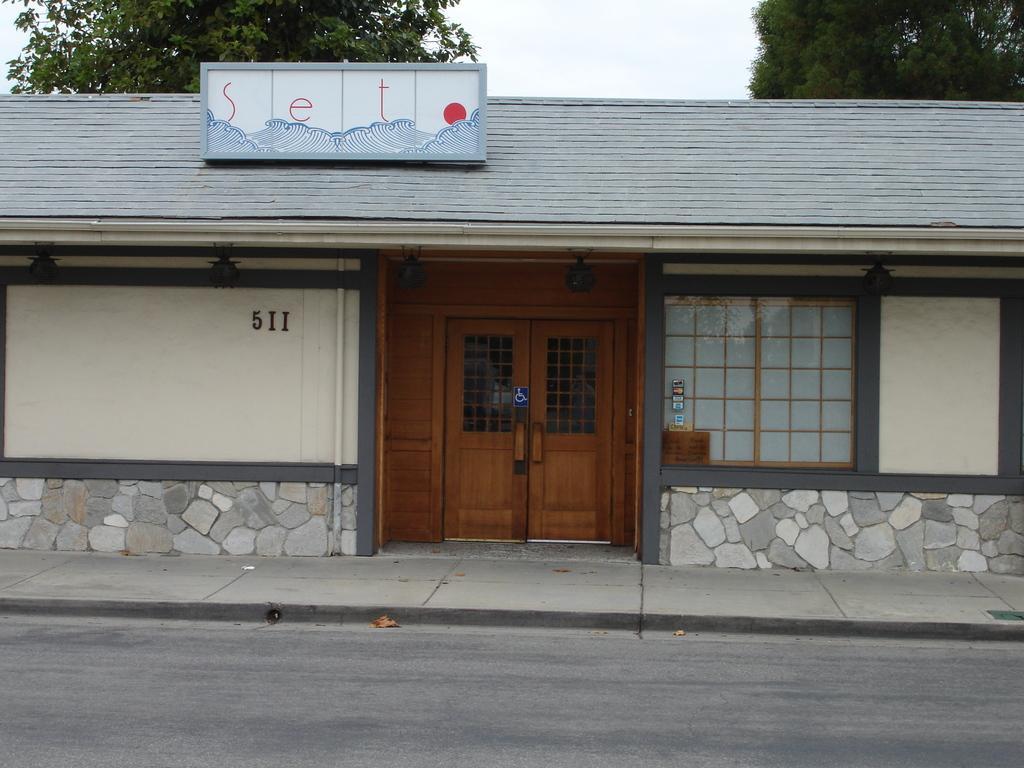Please provide a concise description of this image. This is the picture of a building. In this image there is a building. In the middle of the image there is a door and there is a pipe on the wall and there is a hoarding on the top of the building. At the back there are trees. At the top there is sky. At the bottom there is a road and footpath. 